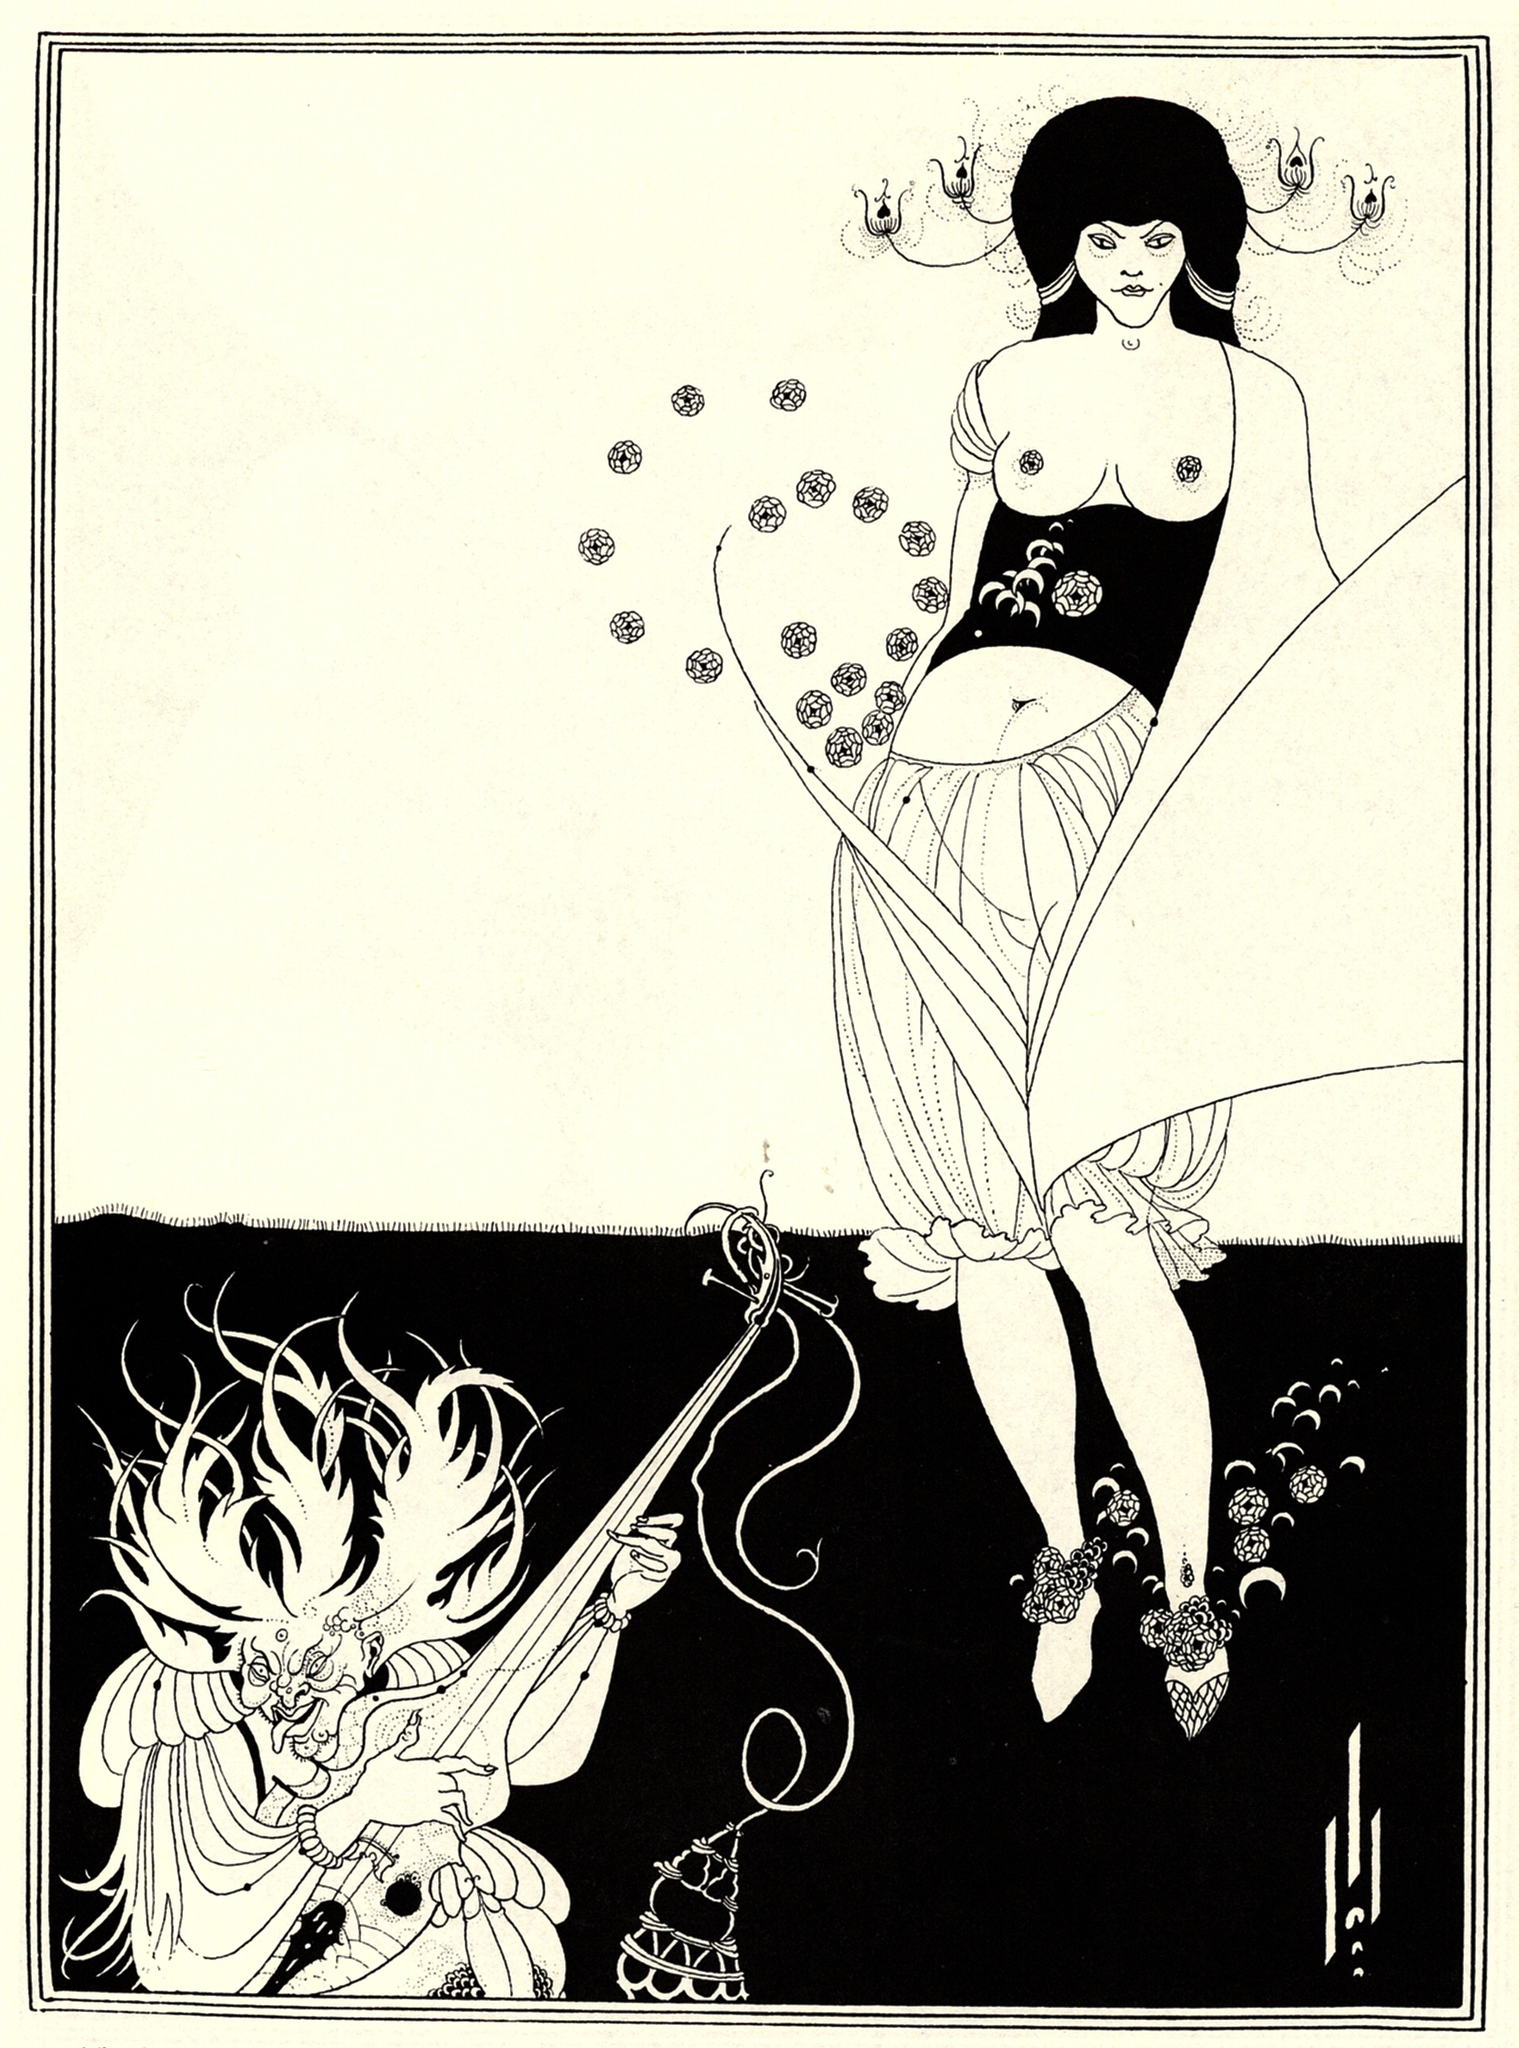If this scene was part of a story, what would be the possible plot surrounding these characters? In a story featuring this scene, the woman could be portrayed as a high priestess or a powerful sorceress engaged in a ceremonial duel or a ritualistic battle with the dragon, which might be a guardian of ancient secrets or a malevolent creature testing her strength and purity. As she faces the dragon with determination, the story could delve into themes of inner strength, the battle between good and evil, and the wisdom that comes from facing one’s deepest fears. The plot would unfold around her quest, perhaps to protect her realm or to seek hidden knowledge guarded by the dragon, leading to a climax where she must draw upon all her abilities and beliefs to prevail. 